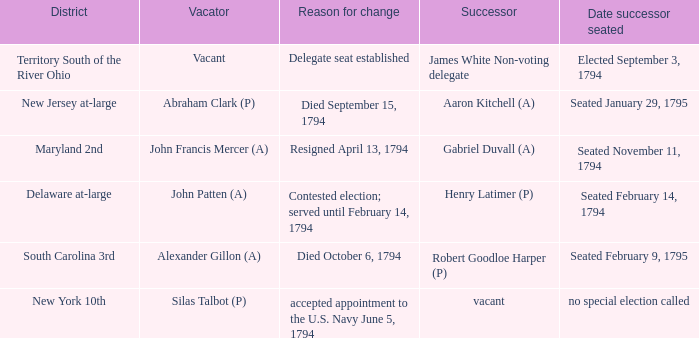Name the date successor seated is south carolina 3rd Seated February 9, 1795. 